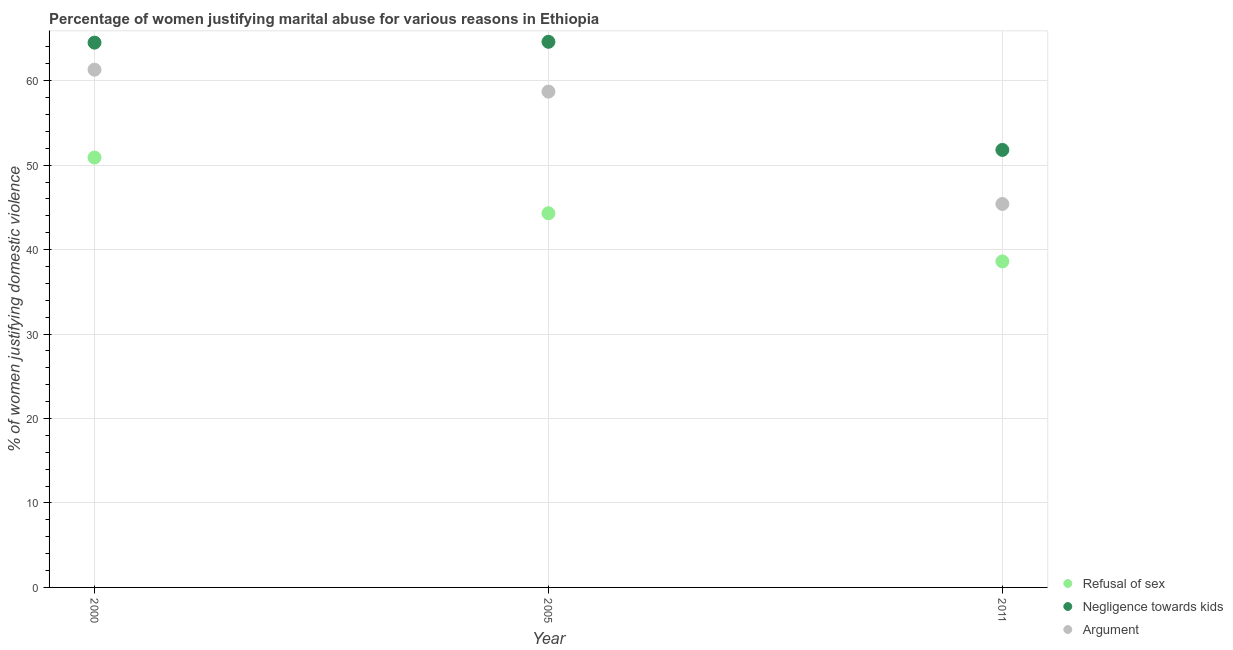Is the number of dotlines equal to the number of legend labels?
Give a very brief answer. Yes. What is the percentage of women justifying domestic violence due to negligence towards kids in 2000?
Ensure brevity in your answer.  64.5. Across all years, what is the maximum percentage of women justifying domestic violence due to negligence towards kids?
Offer a terse response. 64.6. Across all years, what is the minimum percentage of women justifying domestic violence due to arguments?
Offer a very short reply. 45.4. In which year was the percentage of women justifying domestic violence due to refusal of sex maximum?
Provide a succinct answer. 2000. In which year was the percentage of women justifying domestic violence due to arguments minimum?
Provide a succinct answer. 2011. What is the total percentage of women justifying domestic violence due to negligence towards kids in the graph?
Offer a very short reply. 180.9. What is the difference between the percentage of women justifying domestic violence due to arguments in 2000 and that in 2005?
Your answer should be compact. 2.6. What is the difference between the percentage of women justifying domestic violence due to arguments in 2000 and the percentage of women justifying domestic violence due to refusal of sex in 2005?
Offer a terse response. 17. What is the average percentage of women justifying domestic violence due to negligence towards kids per year?
Provide a short and direct response. 60.3. In the year 2011, what is the difference between the percentage of women justifying domestic violence due to arguments and percentage of women justifying domestic violence due to negligence towards kids?
Ensure brevity in your answer.  -6.4. What is the ratio of the percentage of women justifying domestic violence due to arguments in 2005 to that in 2011?
Give a very brief answer. 1.29. Is the percentage of women justifying domestic violence due to arguments in 2005 less than that in 2011?
Offer a very short reply. No. What is the difference between the highest and the second highest percentage of women justifying domestic violence due to negligence towards kids?
Provide a short and direct response. 0.1. What is the difference between the highest and the lowest percentage of women justifying domestic violence due to negligence towards kids?
Your answer should be very brief. 12.8. In how many years, is the percentage of women justifying domestic violence due to negligence towards kids greater than the average percentage of women justifying domestic violence due to negligence towards kids taken over all years?
Provide a short and direct response. 2. Is the sum of the percentage of women justifying domestic violence due to negligence towards kids in 2000 and 2011 greater than the maximum percentage of women justifying domestic violence due to arguments across all years?
Give a very brief answer. Yes. Does the percentage of women justifying domestic violence due to refusal of sex monotonically increase over the years?
Make the answer very short. No. Is the percentage of women justifying domestic violence due to arguments strictly greater than the percentage of women justifying domestic violence due to negligence towards kids over the years?
Ensure brevity in your answer.  No. How many years are there in the graph?
Give a very brief answer. 3. What is the difference between two consecutive major ticks on the Y-axis?
Provide a short and direct response. 10. Are the values on the major ticks of Y-axis written in scientific E-notation?
Your answer should be very brief. No. Does the graph contain any zero values?
Provide a short and direct response. No. Where does the legend appear in the graph?
Provide a short and direct response. Bottom right. How many legend labels are there?
Provide a short and direct response. 3. How are the legend labels stacked?
Make the answer very short. Vertical. What is the title of the graph?
Offer a terse response. Percentage of women justifying marital abuse for various reasons in Ethiopia. What is the label or title of the Y-axis?
Offer a terse response. % of women justifying domestic violence. What is the % of women justifying domestic violence in Refusal of sex in 2000?
Offer a very short reply. 50.9. What is the % of women justifying domestic violence in Negligence towards kids in 2000?
Make the answer very short. 64.5. What is the % of women justifying domestic violence of Argument in 2000?
Your answer should be compact. 61.3. What is the % of women justifying domestic violence of Refusal of sex in 2005?
Keep it short and to the point. 44.3. What is the % of women justifying domestic violence of Negligence towards kids in 2005?
Your answer should be very brief. 64.6. What is the % of women justifying domestic violence in Argument in 2005?
Ensure brevity in your answer.  58.7. What is the % of women justifying domestic violence in Refusal of sex in 2011?
Ensure brevity in your answer.  38.6. What is the % of women justifying domestic violence of Negligence towards kids in 2011?
Ensure brevity in your answer.  51.8. What is the % of women justifying domestic violence in Argument in 2011?
Offer a terse response. 45.4. Across all years, what is the maximum % of women justifying domestic violence in Refusal of sex?
Make the answer very short. 50.9. Across all years, what is the maximum % of women justifying domestic violence in Negligence towards kids?
Provide a short and direct response. 64.6. Across all years, what is the maximum % of women justifying domestic violence of Argument?
Provide a succinct answer. 61.3. Across all years, what is the minimum % of women justifying domestic violence in Refusal of sex?
Provide a short and direct response. 38.6. Across all years, what is the minimum % of women justifying domestic violence in Negligence towards kids?
Offer a very short reply. 51.8. Across all years, what is the minimum % of women justifying domestic violence in Argument?
Provide a succinct answer. 45.4. What is the total % of women justifying domestic violence in Refusal of sex in the graph?
Make the answer very short. 133.8. What is the total % of women justifying domestic violence in Negligence towards kids in the graph?
Provide a short and direct response. 180.9. What is the total % of women justifying domestic violence in Argument in the graph?
Your response must be concise. 165.4. What is the difference between the % of women justifying domestic violence in Negligence towards kids in 2000 and that in 2011?
Your response must be concise. 12.7. What is the difference between the % of women justifying domestic violence in Argument in 2000 and that in 2011?
Your answer should be very brief. 15.9. What is the difference between the % of women justifying domestic violence in Refusal of sex in 2005 and that in 2011?
Offer a terse response. 5.7. What is the difference between the % of women justifying domestic violence of Argument in 2005 and that in 2011?
Offer a very short reply. 13.3. What is the difference between the % of women justifying domestic violence of Refusal of sex in 2000 and the % of women justifying domestic violence of Negligence towards kids in 2005?
Keep it short and to the point. -13.7. What is the difference between the % of women justifying domestic violence in Refusal of sex in 2000 and the % of women justifying domestic violence in Argument in 2005?
Provide a succinct answer. -7.8. What is the difference between the % of women justifying domestic violence of Negligence towards kids in 2000 and the % of women justifying domestic violence of Argument in 2005?
Your response must be concise. 5.8. What is the difference between the % of women justifying domestic violence of Refusal of sex in 2000 and the % of women justifying domestic violence of Argument in 2011?
Make the answer very short. 5.5. What is the difference between the % of women justifying domestic violence of Negligence towards kids in 2000 and the % of women justifying domestic violence of Argument in 2011?
Keep it short and to the point. 19.1. What is the difference between the % of women justifying domestic violence in Refusal of sex in 2005 and the % of women justifying domestic violence in Negligence towards kids in 2011?
Offer a terse response. -7.5. What is the average % of women justifying domestic violence of Refusal of sex per year?
Provide a short and direct response. 44.6. What is the average % of women justifying domestic violence in Negligence towards kids per year?
Your answer should be compact. 60.3. What is the average % of women justifying domestic violence of Argument per year?
Offer a very short reply. 55.13. In the year 2000, what is the difference between the % of women justifying domestic violence of Refusal of sex and % of women justifying domestic violence of Negligence towards kids?
Keep it short and to the point. -13.6. In the year 2000, what is the difference between the % of women justifying domestic violence of Negligence towards kids and % of women justifying domestic violence of Argument?
Ensure brevity in your answer.  3.2. In the year 2005, what is the difference between the % of women justifying domestic violence of Refusal of sex and % of women justifying domestic violence of Negligence towards kids?
Make the answer very short. -20.3. In the year 2005, what is the difference between the % of women justifying domestic violence in Refusal of sex and % of women justifying domestic violence in Argument?
Make the answer very short. -14.4. In the year 2011, what is the difference between the % of women justifying domestic violence of Refusal of sex and % of women justifying domestic violence of Negligence towards kids?
Make the answer very short. -13.2. In the year 2011, what is the difference between the % of women justifying domestic violence in Refusal of sex and % of women justifying domestic violence in Argument?
Make the answer very short. -6.8. What is the ratio of the % of women justifying domestic violence in Refusal of sex in 2000 to that in 2005?
Provide a succinct answer. 1.15. What is the ratio of the % of women justifying domestic violence in Negligence towards kids in 2000 to that in 2005?
Your answer should be compact. 1. What is the ratio of the % of women justifying domestic violence of Argument in 2000 to that in 2005?
Your answer should be very brief. 1.04. What is the ratio of the % of women justifying domestic violence in Refusal of sex in 2000 to that in 2011?
Give a very brief answer. 1.32. What is the ratio of the % of women justifying domestic violence of Negligence towards kids in 2000 to that in 2011?
Your answer should be very brief. 1.25. What is the ratio of the % of women justifying domestic violence in Argument in 2000 to that in 2011?
Your response must be concise. 1.35. What is the ratio of the % of women justifying domestic violence in Refusal of sex in 2005 to that in 2011?
Provide a succinct answer. 1.15. What is the ratio of the % of women justifying domestic violence in Negligence towards kids in 2005 to that in 2011?
Provide a succinct answer. 1.25. What is the ratio of the % of women justifying domestic violence of Argument in 2005 to that in 2011?
Give a very brief answer. 1.29. What is the difference between the highest and the second highest % of women justifying domestic violence of Refusal of sex?
Offer a very short reply. 6.6. What is the difference between the highest and the second highest % of women justifying domestic violence in Argument?
Provide a short and direct response. 2.6. What is the difference between the highest and the lowest % of women justifying domestic violence in Refusal of sex?
Give a very brief answer. 12.3. What is the difference between the highest and the lowest % of women justifying domestic violence of Argument?
Offer a terse response. 15.9. 